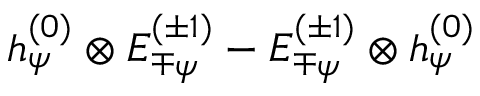Convert formula to latex. <formula><loc_0><loc_0><loc_500><loc_500>h _ { \psi } ^ { ( 0 ) } \otimes E _ { \mp \psi } ^ { ( \pm 1 ) } - E _ { \mp \psi } ^ { ( \pm 1 ) } \otimes h _ { \psi } ^ { ( 0 ) }</formula> 